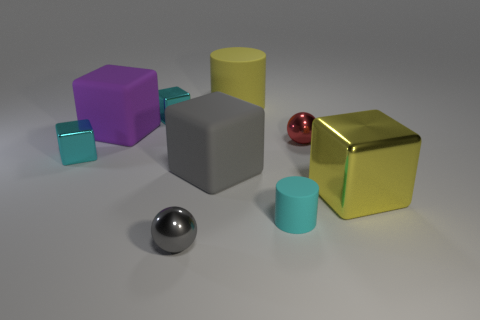Subtract all cyan blocks. How many blocks are left? 3 Subtract all yellow blocks. How many blocks are left? 4 Subtract all gray cubes. Subtract all yellow spheres. How many cubes are left? 4 Add 1 small blue matte objects. How many objects exist? 10 Subtract all cylinders. How many objects are left? 7 Subtract 0 green blocks. How many objects are left? 9 Subtract all tiny red matte cubes. Subtract all purple rubber things. How many objects are left? 8 Add 7 small cyan metallic objects. How many small cyan metallic objects are left? 9 Add 7 large cylinders. How many large cylinders exist? 8 